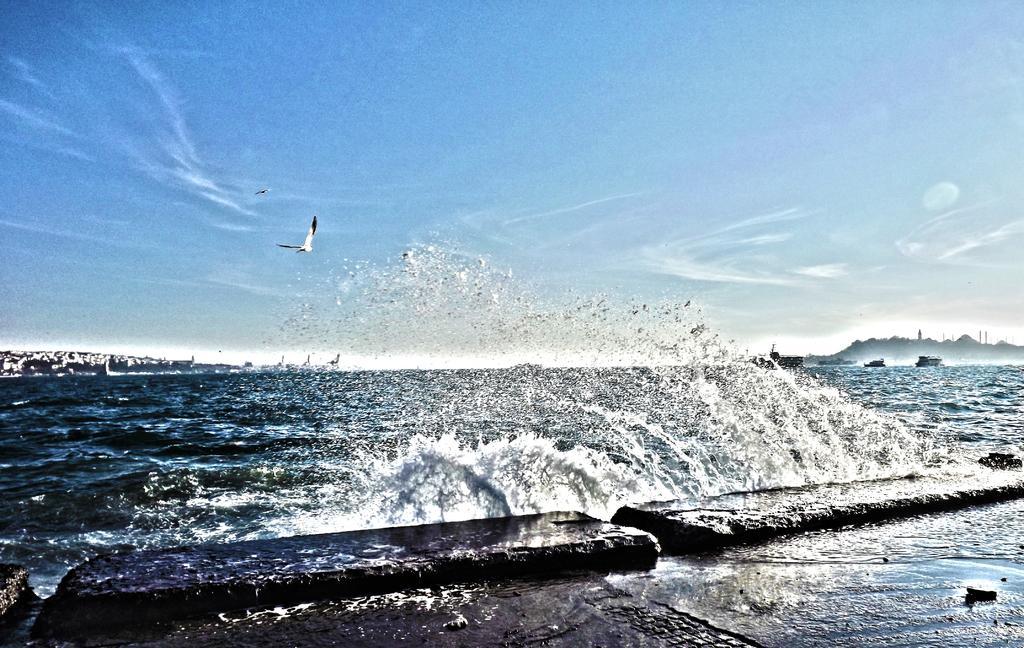Please provide a concise description of this image. In the center of the image, we can see a bird flying and at the bottom, there is water. At the top, there is sky. 